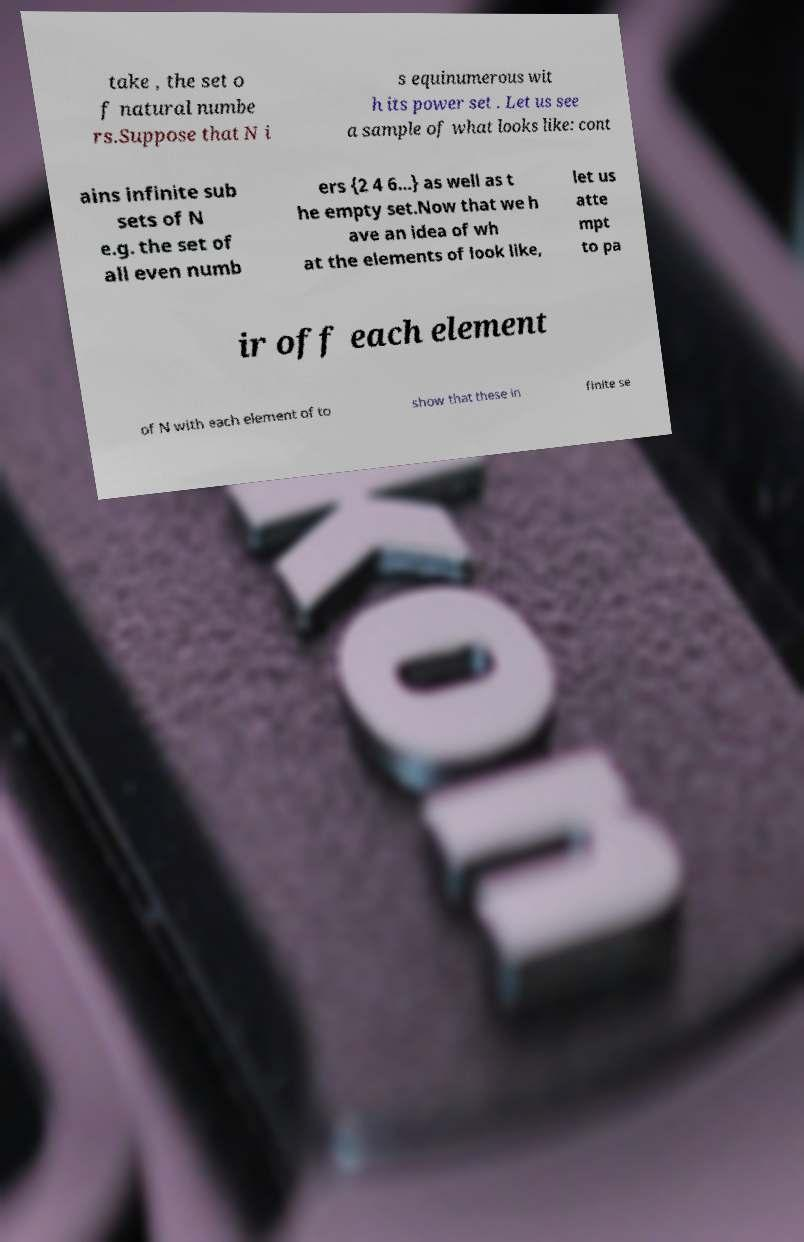Please identify and transcribe the text found in this image. take , the set o f natural numbe rs.Suppose that N i s equinumerous wit h its power set . Let us see a sample of what looks like: cont ains infinite sub sets of N e.g. the set of all even numb ers {2 4 6...} as well as t he empty set.Now that we h ave an idea of wh at the elements of look like, let us atte mpt to pa ir off each element of N with each element of to show that these in finite se 